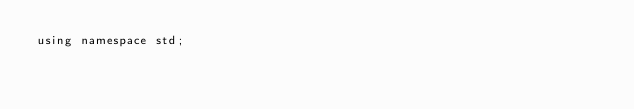Convert code to text. <code><loc_0><loc_0><loc_500><loc_500><_Cuda_>using namespace std;

</code> 